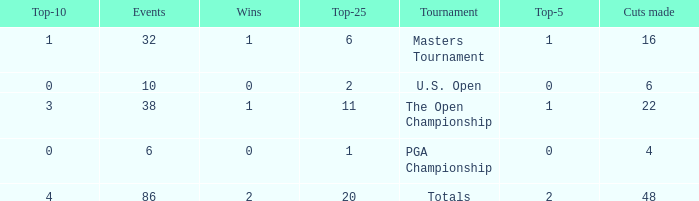Tell me the total number of top 25 for wins less than 1 and cuts made of 22 0.0. 